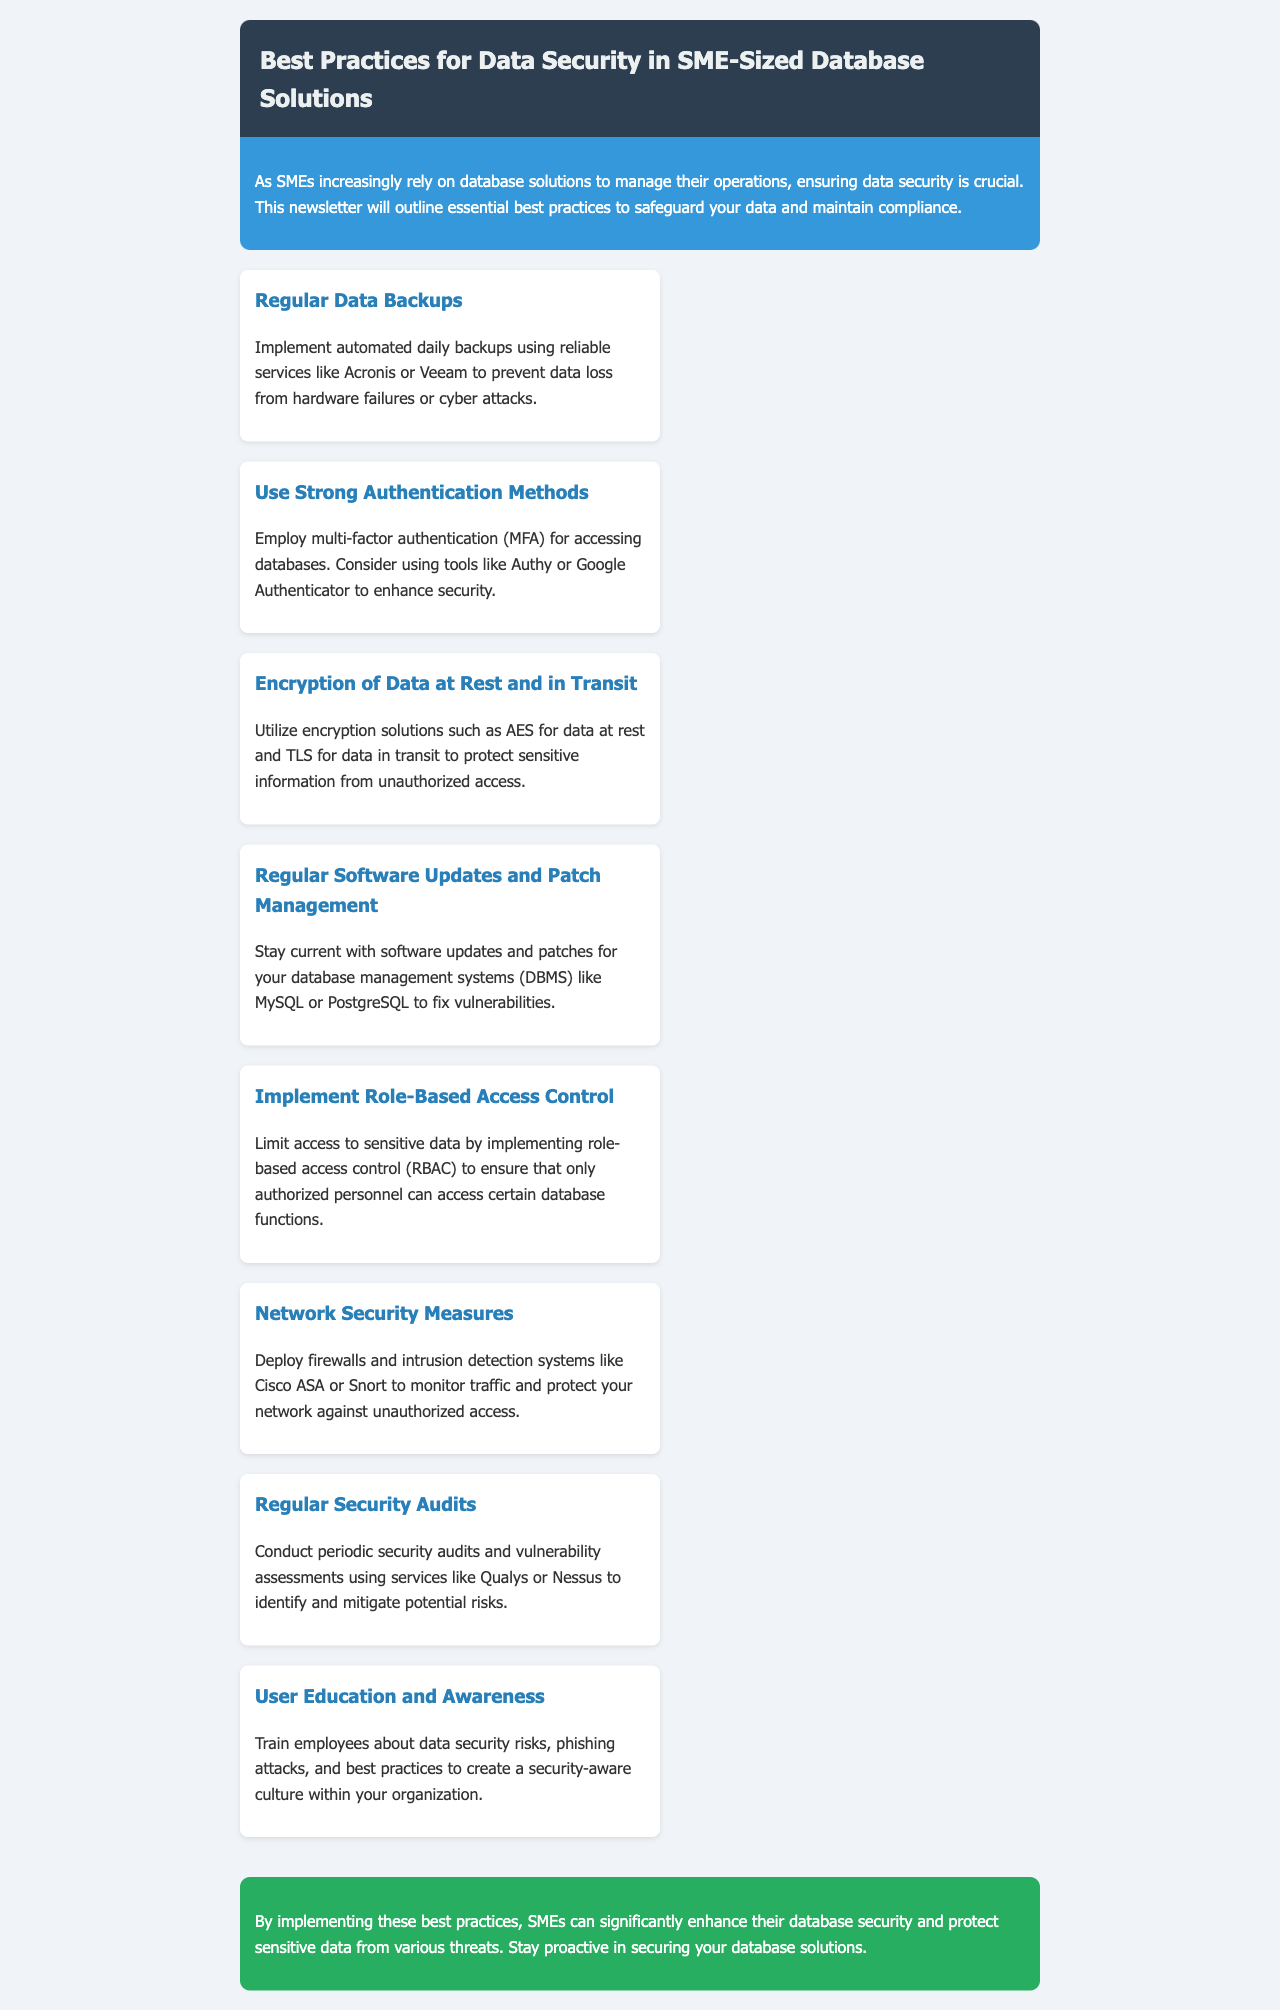What is the title of the newsletter? The title is stated in the header of the document.
Answer: Best Practices for Data Security in SME-Sized Database Solutions How many best practices are mentioned in the newsletter? The number of practices can be counted in the list provided in the document.
Answer: Eight What is recommended for regular data backups? The document specifies tools for data backups.
Answer: Acronis or Veeam What type of authentication method should be employed? The document suggests a specific security method for database access.
Answer: Multi-factor authentication Which encryption solution is suggested for data at rest? The newsletter mentions the type of encryption to protect stored data.
Answer: AES What does RBAC stand for? The acronym is defined in the context of database access control in the document.
Answer: Role-Based Access Control What tool is recommended for conducting periodic security audits? The newsletter includes services for security audits.
Answer: Qualys or Nessus Which employee educational aspect is emphasized in the newsletter? The document highlights a specific area of training for employees.
Answer: Data security risks 